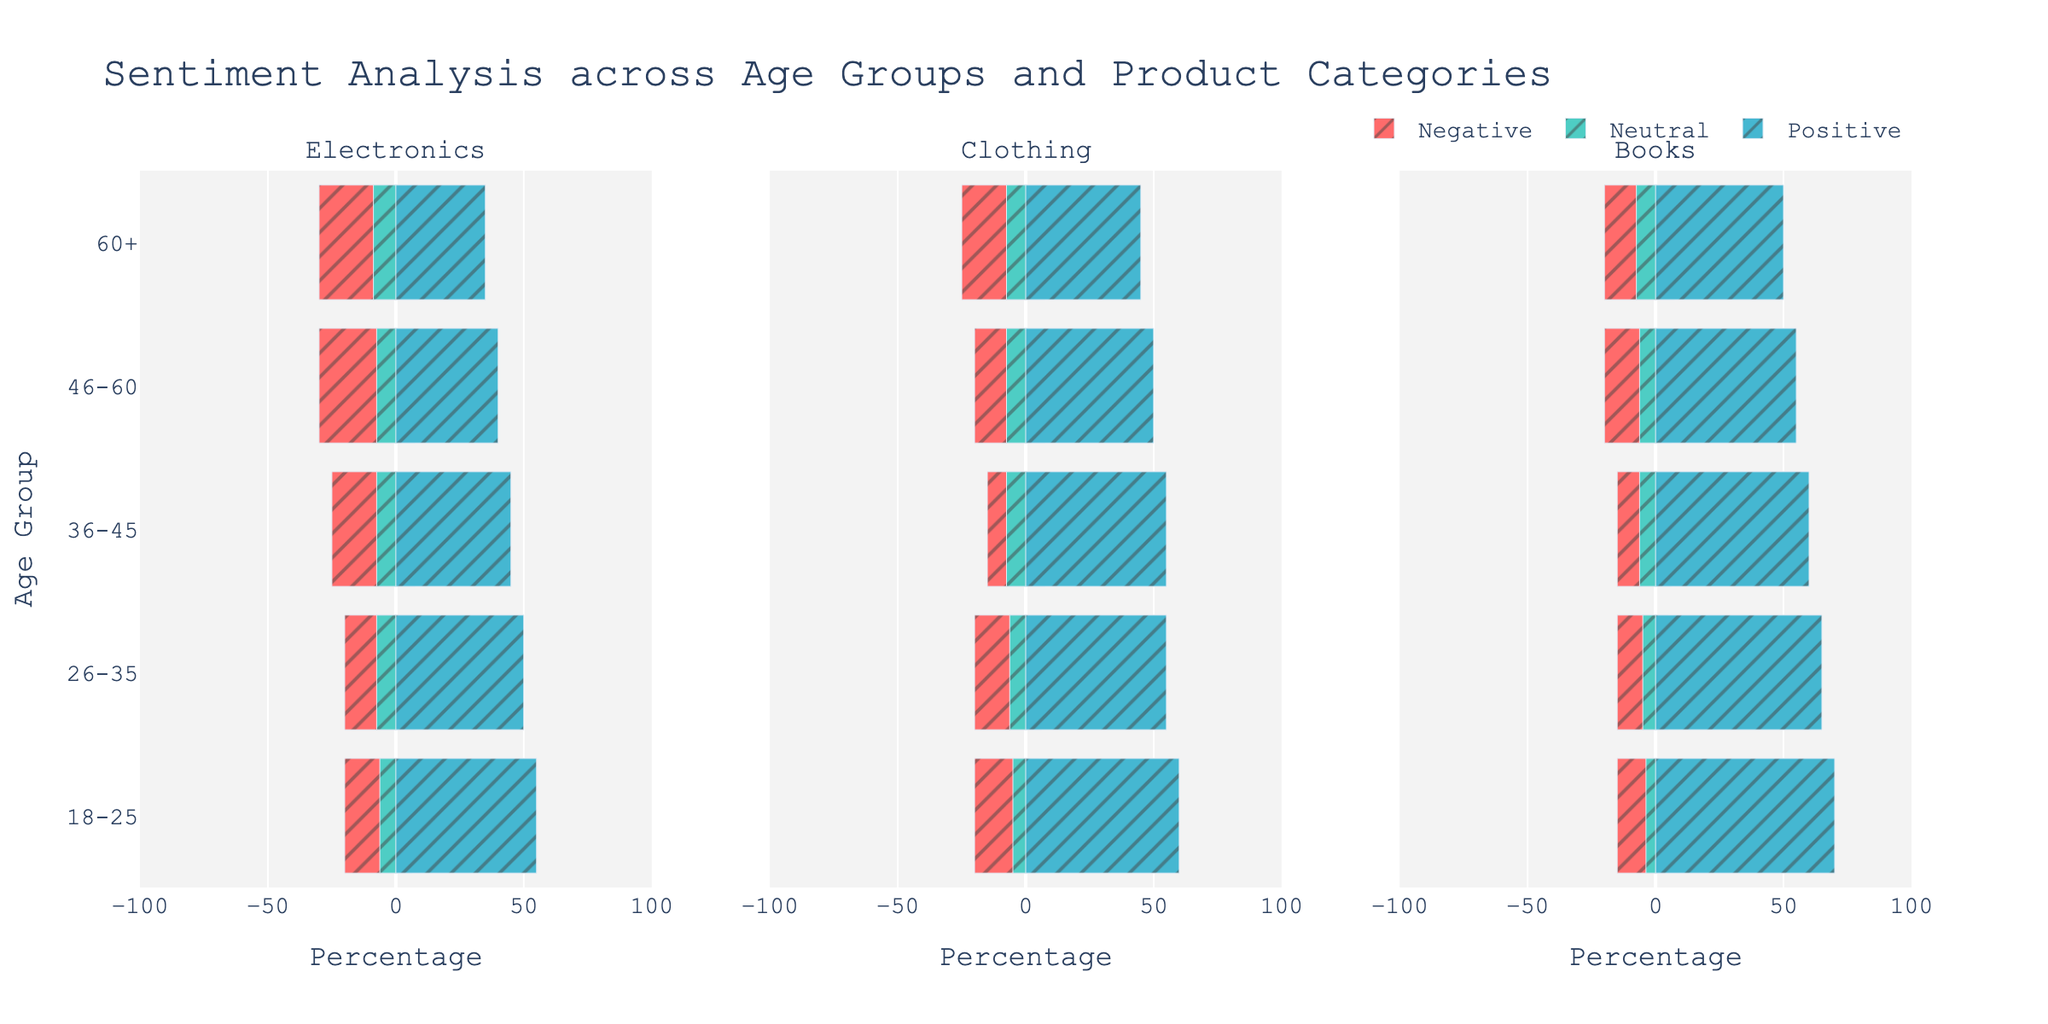What is the sentiment composition for the 18-25 age group in the Electronics category? First, locate the bar for the 18-25 age group under the Electronics sub-plot. The bar shows 55% Positive, 25% Neutral, and 20% Negative sentiments.
Answer: 55% Positive, 25% Neutral, 20% Negative Which age group has the highest positive sentiment for Books? Identify the bar representing Positive sentiment in the Books sub-plot and compare across all age groups. The 18-25 age group shows the highest positive sentiment at 70%.
Answer: 18-25 What is the total percentage of negative sentiments for Electronics across all age groups? Add the negative sentiment percentages for Electronics across all age groups: 20 + 20 + 25 + 30 + 30 = 125%.
Answer: 125% Compare the Neutral sentiment for Electronics and Clothing in the 46-60 age group. Which is higher? Look at the bars for the 46-60 age group in both Electronics and Clothing. Electronics has 30% Neutral and Clothing has 30% Neutral. Both are equal.
Answer: Equal What is the overall trend in positive sentiments for the Clothing category across age groups? Observe the bars for Positive sentiment within the Clothing category for each age group: 60% (18-25), 55% (26-35), 55% (36-45), 50% (46-60), 45% (60+). The trend shows a gradual decrease as age increases.
Answer: Decreasing Which age group has the most balanced sentiment distribution for Books? Balanced means close percentages across all sentiments. The 36-45 age group has 60% Positive, 25% Neutral, and 15% Negative, which is relatively balanced.
Answer: 36-45 What is the ratio of positive to negative sentiments for Clothing in the 26-35 age group? Locate the Clothing category bar for the 26-35 age group: 55% Positive, 20% Negative. The ratio is 55:20, which simplifies to 11:4.
Answer: 11:4 Is there an age group where negative sentiment is higher than positive sentiment for any category? Compare the lengths of Negative sentiment bars to Positive sentiment bars across all categories and age groups. No such age group where negative sentiment is higher than positive sentiment.
Answer: No For all age groups combined, which product category has the highest average positive sentiment? Calculate the average of Positive sentiment for each category:
- Electronics: (55 + 50 + 45 + 40 + 35) / 5 = 45%
- Clothing: (60 + 55 + 55 + 50 + 45) / 5 = 53%
- Books: (70 + 65 + 60 + 55 + 50) / 5 = 60%
Books has the highest average positive sentiment.
Answer: Books 